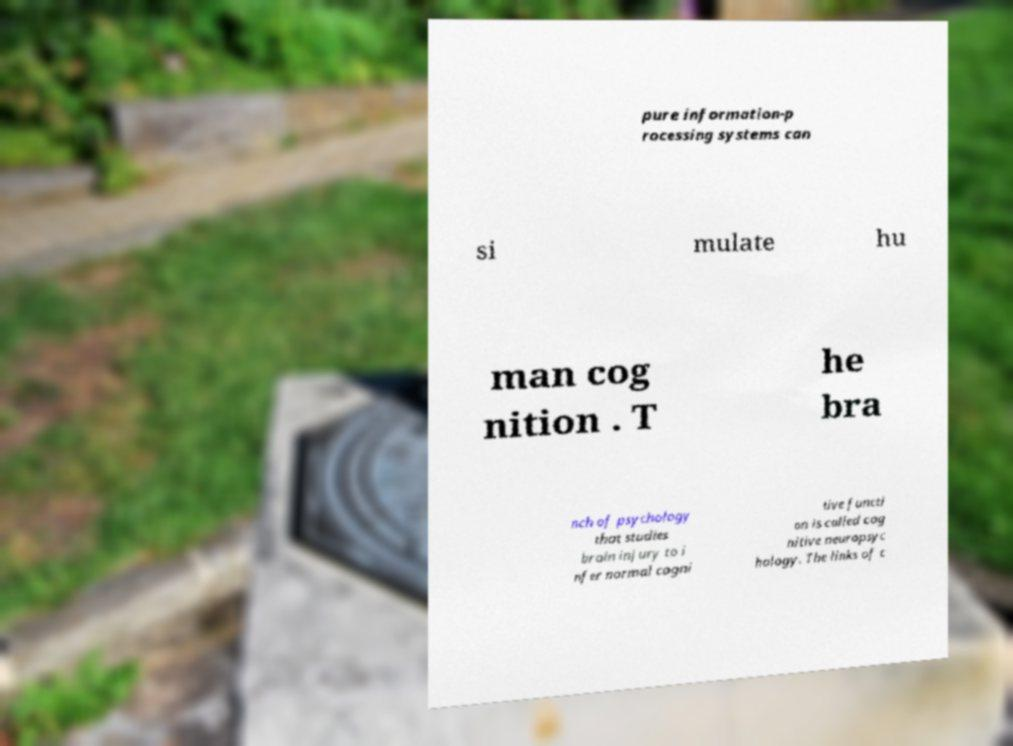Could you extract and type out the text from this image? pure information-p rocessing systems can si mulate hu man cog nition . T he bra nch of psychology that studies brain injury to i nfer normal cogni tive functi on is called cog nitive neuropsyc hology. The links of c 